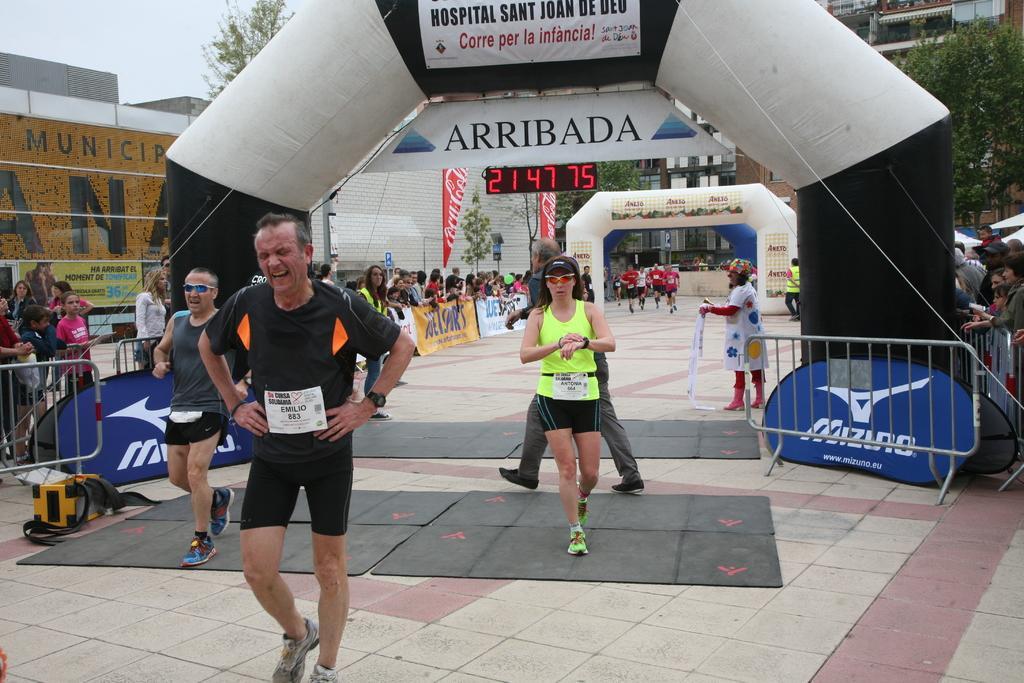How would you summarize this image in a sentence or two? In this picture I can see there are few people running and this person is wearing a black color jersey and in the backdrop I can see there are few more people running and wearing red jerseys and there are buildings here and the sky is clear. 